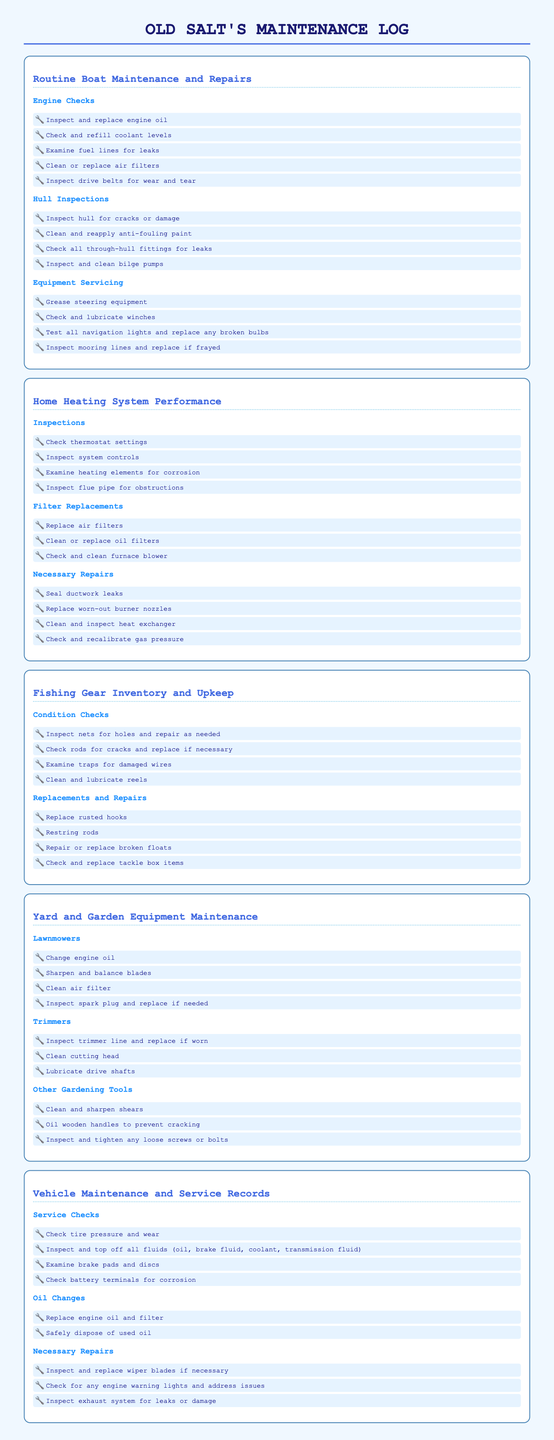what tasks are included in Engine Checks? The document lists tasks such as inspecting and replacing engine oil, checking and refilling coolant levels, and examining fuel lines for leaks under Engine Checks.
Answer: Inspect and replace engine oil, check and refill coolant levels, examine fuel lines for leaks, clean or replace air filters, inspect drive belts for wear and tear how often do air filters need to be replaced in the Home Heating System? The document highlights that air filters should be replaced monthly as a part of the filter replacements section under the Home Heating System Performance.
Answer: Monthly what should be done to lawnmowers during maintenance? The lawnmower maintenance includes changing engine oil, sharpening and balancing blades, cleaning the air filter, and inspecting the spark plug.
Answer: Change engine oil, sharpen and balance blades, clean air filter, inspect spark plug what is done to ensure fishing gear is in good condition? The Fishing Gear Inventory and Upkeep section outlines condition checks such as inspecting nets for holes, checking rods for cracks, and examining traps for damaged wires to ensure the gear's condition.
Answer: Inspect nets for holes, check rods for cracks, examine traps for damaged wires what is a necessary repair for the vehicle maintenance log? Necessary repairs mentioned include inspecting and replacing wiper blades, checking engine warning lights, and inspecting the exhaust system for leaks or damage in the Vehicle Maintenance and Service Records section.
Answer: Inspect and replace wiper blades, check for any engine warning lights, inspect exhaust system for leaks or damage which section contains checks for thermostat settings? The Home Heating System Performance section contains checks for thermostat settings.
Answer: Home Heating System Performance how many tasks are there listed under Hull Inspections? There are four tasks listed under Hull Inspections including inspecting the hull for cracks, cleaning and reapplying anti-fouling paint, checking fittings for leaks, and inspecting bilge pumps.
Answer: Four what type of equipment is serviced in the Routine Boat Maintenance and Repairs? The Routine Boat Maintenance and Repairs includes servicing equipment like steering equipment, winches, navigation lights, and mooring lines.
Answer: Steering equipment, winches, navigation lights, mooring lines what action is suggested for damaged fishing nets? The document suggests that damaged fishing nets should be inspected for holes and repaired as needed.
Answer: Inspect nets for holes and repair as needed 